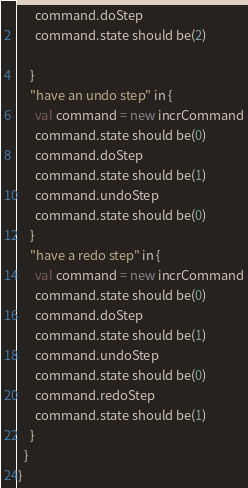<code> <loc_0><loc_0><loc_500><loc_500><_Scala_>      command.doStep
      command.state should be(2)

    }
    "have an undo step" in {
      val command = new incrCommand
      command.state should be(0)
      command.doStep
      command.state should be(1)
      command.undoStep
      command.state should be(0)
    }
    "have a redo step" in {
      val command = new incrCommand
      command.state should be(0)
      command.doStep
      command.state should be(1)
      command.undoStep
      command.state should be(0)
      command.redoStep
      command.state should be(1)
    }
  }
}
</code> 